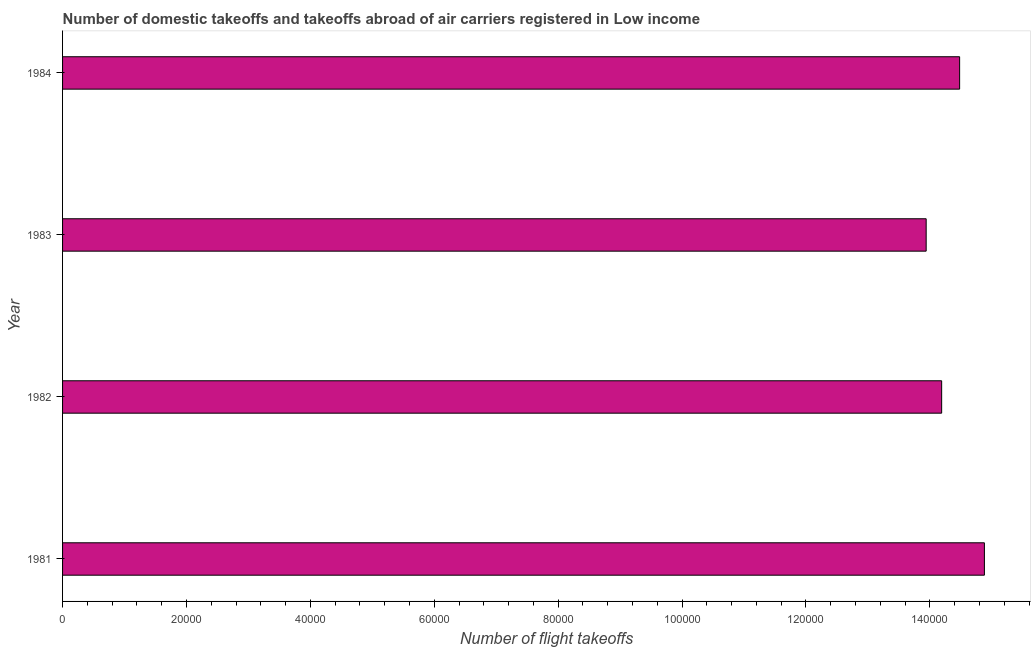Does the graph contain grids?
Give a very brief answer. No. What is the title of the graph?
Offer a terse response. Number of domestic takeoffs and takeoffs abroad of air carriers registered in Low income. What is the label or title of the X-axis?
Provide a short and direct response. Number of flight takeoffs. What is the label or title of the Y-axis?
Make the answer very short. Year. What is the number of flight takeoffs in 1983?
Offer a terse response. 1.39e+05. Across all years, what is the maximum number of flight takeoffs?
Your answer should be compact. 1.49e+05. Across all years, what is the minimum number of flight takeoffs?
Give a very brief answer. 1.39e+05. In which year was the number of flight takeoffs maximum?
Offer a very short reply. 1981. What is the sum of the number of flight takeoffs?
Your answer should be compact. 5.75e+05. What is the difference between the number of flight takeoffs in 1982 and 1983?
Provide a succinct answer. 2500. What is the average number of flight takeoffs per year?
Make the answer very short. 1.44e+05. What is the median number of flight takeoffs?
Your response must be concise. 1.43e+05. Is the number of flight takeoffs in 1982 less than that in 1984?
Your response must be concise. Yes. Is the difference between the number of flight takeoffs in 1981 and 1982 greater than the difference between any two years?
Your answer should be compact. No. What is the difference between the highest and the second highest number of flight takeoffs?
Provide a succinct answer. 4000. What is the difference between the highest and the lowest number of flight takeoffs?
Your answer should be very brief. 9400. In how many years, is the number of flight takeoffs greater than the average number of flight takeoffs taken over all years?
Give a very brief answer. 2. How many bars are there?
Your answer should be compact. 4. Are all the bars in the graph horizontal?
Offer a very short reply. Yes. How many years are there in the graph?
Keep it short and to the point. 4. What is the difference between two consecutive major ticks on the X-axis?
Offer a very short reply. 2.00e+04. Are the values on the major ticks of X-axis written in scientific E-notation?
Provide a short and direct response. No. What is the Number of flight takeoffs in 1981?
Make the answer very short. 1.49e+05. What is the Number of flight takeoffs of 1982?
Provide a short and direct response. 1.42e+05. What is the Number of flight takeoffs in 1983?
Your answer should be very brief. 1.39e+05. What is the Number of flight takeoffs in 1984?
Offer a terse response. 1.45e+05. What is the difference between the Number of flight takeoffs in 1981 and 1982?
Your answer should be compact. 6900. What is the difference between the Number of flight takeoffs in 1981 and 1983?
Your answer should be very brief. 9400. What is the difference between the Number of flight takeoffs in 1981 and 1984?
Make the answer very short. 4000. What is the difference between the Number of flight takeoffs in 1982 and 1983?
Provide a succinct answer. 2500. What is the difference between the Number of flight takeoffs in 1982 and 1984?
Give a very brief answer. -2900. What is the difference between the Number of flight takeoffs in 1983 and 1984?
Give a very brief answer. -5400. What is the ratio of the Number of flight takeoffs in 1981 to that in 1982?
Your answer should be compact. 1.05. What is the ratio of the Number of flight takeoffs in 1981 to that in 1983?
Provide a short and direct response. 1.07. What is the ratio of the Number of flight takeoffs in 1981 to that in 1984?
Provide a succinct answer. 1.03. What is the ratio of the Number of flight takeoffs in 1982 to that in 1983?
Ensure brevity in your answer.  1.02. What is the ratio of the Number of flight takeoffs in 1983 to that in 1984?
Your answer should be very brief. 0.96. 